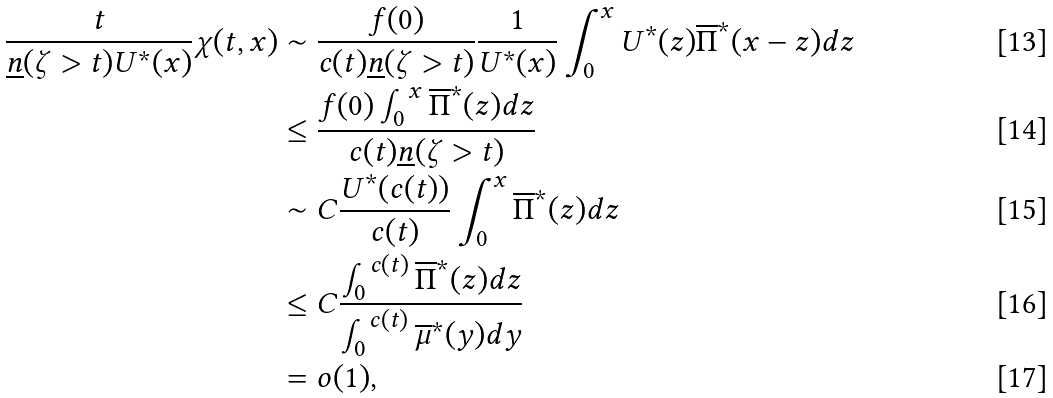<formula> <loc_0><loc_0><loc_500><loc_500>\frac { t } { \underline { n } ( \zeta > t ) U ^ { \ast } ( x ) } \chi ( t , x ) & \sim \frac { f ( 0 ) } { c ( t ) \underline { n } ( \zeta > t ) } \frac { 1 } { U ^ { \ast } ( x ) } \int _ { 0 } ^ { x } U ^ { \ast } ( z ) \overline { \Pi } ^ { \ast } ( x - z ) d z \\ & \leq \frac { f ( 0 ) \int _ { 0 } ^ { x } \overline { \Pi } ^ { \ast } ( z ) d z } { c ( t ) \underline { n } ( \zeta > t ) } \\ & \sim C \frac { U ^ { \ast } ( c ( t ) ) } { c ( t ) } \int _ { 0 } ^ { x } \overline { \Pi } ^ { \ast } ( z ) d z \\ & \leq C \frac { \int _ { 0 } ^ { c ( t ) } \overline { \Pi } ^ { \ast } ( z ) d z } { \int ^ { c ( t ) } _ { 0 } \overline { \mu } ^ { * } ( y ) d y } \\ & = o ( 1 ) ,</formula> 